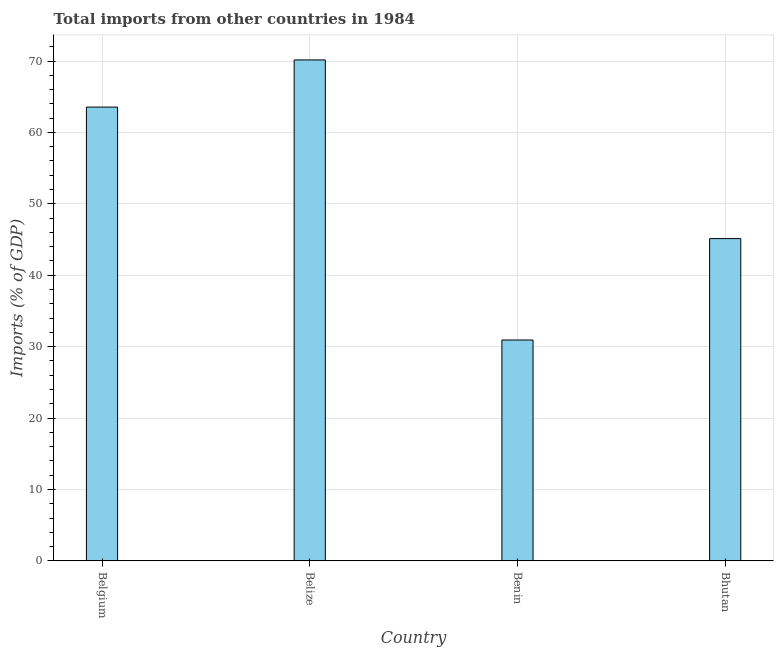Does the graph contain grids?
Your answer should be very brief. Yes. What is the title of the graph?
Ensure brevity in your answer.  Total imports from other countries in 1984. What is the label or title of the X-axis?
Offer a terse response. Country. What is the label or title of the Y-axis?
Ensure brevity in your answer.  Imports (% of GDP). What is the total imports in Belgium?
Your answer should be very brief. 63.55. Across all countries, what is the maximum total imports?
Offer a terse response. 70.15. Across all countries, what is the minimum total imports?
Your answer should be very brief. 30.93. In which country was the total imports maximum?
Provide a short and direct response. Belize. In which country was the total imports minimum?
Your answer should be very brief. Benin. What is the sum of the total imports?
Offer a terse response. 209.76. What is the difference between the total imports in Belgium and Benin?
Make the answer very short. 32.61. What is the average total imports per country?
Your answer should be very brief. 52.44. What is the median total imports?
Provide a short and direct response. 54.34. In how many countries, is the total imports greater than 2 %?
Keep it short and to the point. 4. What is the ratio of the total imports in Belgium to that in Bhutan?
Make the answer very short. 1.41. Is the total imports in Belgium less than that in Bhutan?
Offer a very short reply. No. What is the difference between the highest and the second highest total imports?
Offer a very short reply. 6.61. What is the difference between the highest and the lowest total imports?
Provide a succinct answer. 39.22. In how many countries, is the total imports greater than the average total imports taken over all countries?
Your answer should be very brief. 2. How many bars are there?
Make the answer very short. 4. How many countries are there in the graph?
Your answer should be compact. 4. What is the difference between two consecutive major ticks on the Y-axis?
Give a very brief answer. 10. What is the Imports (% of GDP) of Belgium?
Your answer should be very brief. 63.55. What is the Imports (% of GDP) in Belize?
Your response must be concise. 70.15. What is the Imports (% of GDP) of Benin?
Keep it short and to the point. 30.93. What is the Imports (% of GDP) in Bhutan?
Offer a very short reply. 45.13. What is the difference between the Imports (% of GDP) in Belgium and Belize?
Offer a very short reply. -6.61. What is the difference between the Imports (% of GDP) in Belgium and Benin?
Make the answer very short. 32.61. What is the difference between the Imports (% of GDP) in Belgium and Bhutan?
Give a very brief answer. 18.42. What is the difference between the Imports (% of GDP) in Belize and Benin?
Make the answer very short. 39.22. What is the difference between the Imports (% of GDP) in Belize and Bhutan?
Your answer should be compact. 25.02. What is the difference between the Imports (% of GDP) in Benin and Bhutan?
Make the answer very short. -14.2. What is the ratio of the Imports (% of GDP) in Belgium to that in Belize?
Provide a succinct answer. 0.91. What is the ratio of the Imports (% of GDP) in Belgium to that in Benin?
Provide a succinct answer. 2.05. What is the ratio of the Imports (% of GDP) in Belgium to that in Bhutan?
Give a very brief answer. 1.41. What is the ratio of the Imports (% of GDP) in Belize to that in Benin?
Your answer should be compact. 2.27. What is the ratio of the Imports (% of GDP) in Belize to that in Bhutan?
Give a very brief answer. 1.55. What is the ratio of the Imports (% of GDP) in Benin to that in Bhutan?
Ensure brevity in your answer.  0.69. 